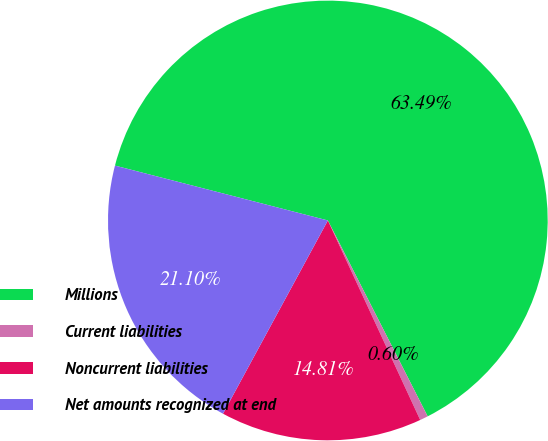Convert chart. <chart><loc_0><loc_0><loc_500><loc_500><pie_chart><fcel>Millions<fcel>Current liabilities<fcel>Noncurrent liabilities<fcel>Net amounts recognized at end<nl><fcel>63.48%<fcel>0.6%<fcel>14.81%<fcel>21.1%<nl></chart> 